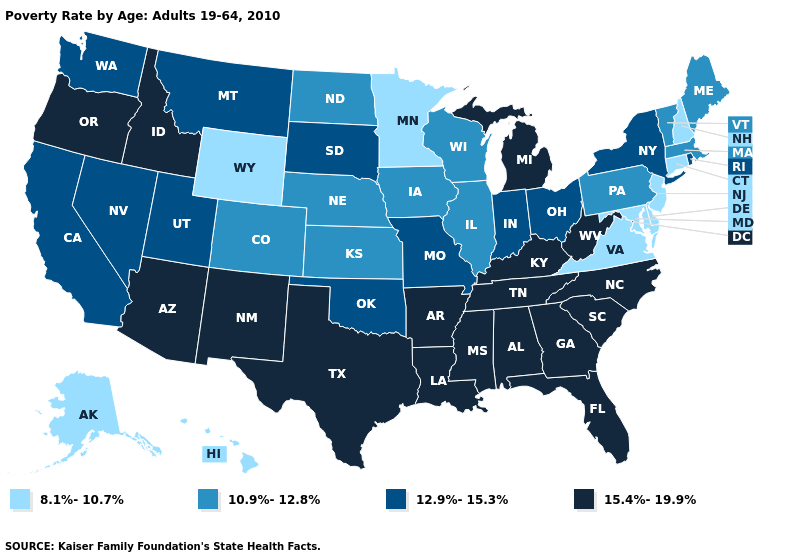Name the states that have a value in the range 15.4%-19.9%?
Concise answer only. Alabama, Arizona, Arkansas, Florida, Georgia, Idaho, Kentucky, Louisiana, Michigan, Mississippi, New Mexico, North Carolina, Oregon, South Carolina, Tennessee, Texas, West Virginia. Does Minnesota have the lowest value in the MidWest?
Concise answer only. Yes. Among the states that border Nevada , which have the highest value?
Keep it brief. Arizona, Idaho, Oregon. Does Louisiana have a lower value than Nevada?
Be succinct. No. How many symbols are there in the legend?
Be succinct. 4. Does the first symbol in the legend represent the smallest category?
Write a very short answer. Yes. Does the map have missing data?
Keep it brief. No. Does Rhode Island have the highest value in the Northeast?
Keep it brief. Yes. How many symbols are there in the legend?
Short answer required. 4. Which states have the lowest value in the USA?
Give a very brief answer. Alaska, Connecticut, Delaware, Hawaii, Maryland, Minnesota, New Hampshire, New Jersey, Virginia, Wyoming. Does Wisconsin have the highest value in the MidWest?
Quick response, please. No. Does Missouri have the lowest value in the MidWest?
Quick response, please. No. Name the states that have a value in the range 15.4%-19.9%?
Be succinct. Alabama, Arizona, Arkansas, Florida, Georgia, Idaho, Kentucky, Louisiana, Michigan, Mississippi, New Mexico, North Carolina, Oregon, South Carolina, Tennessee, Texas, West Virginia. Name the states that have a value in the range 10.9%-12.8%?
Give a very brief answer. Colorado, Illinois, Iowa, Kansas, Maine, Massachusetts, Nebraska, North Dakota, Pennsylvania, Vermont, Wisconsin. Which states hav the highest value in the West?
Give a very brief answer. Arizona, Idaho, New Mexico, Oregon. 